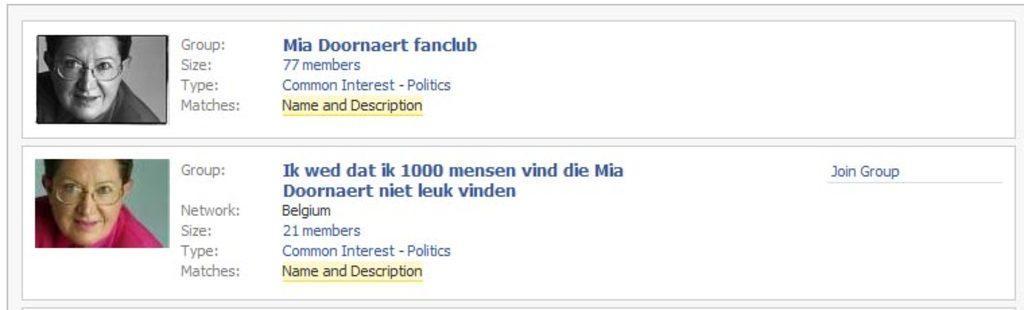Please provide a concise description of this image. In this image we can see a monitor screen on which we can see two photos and some text written on it. 